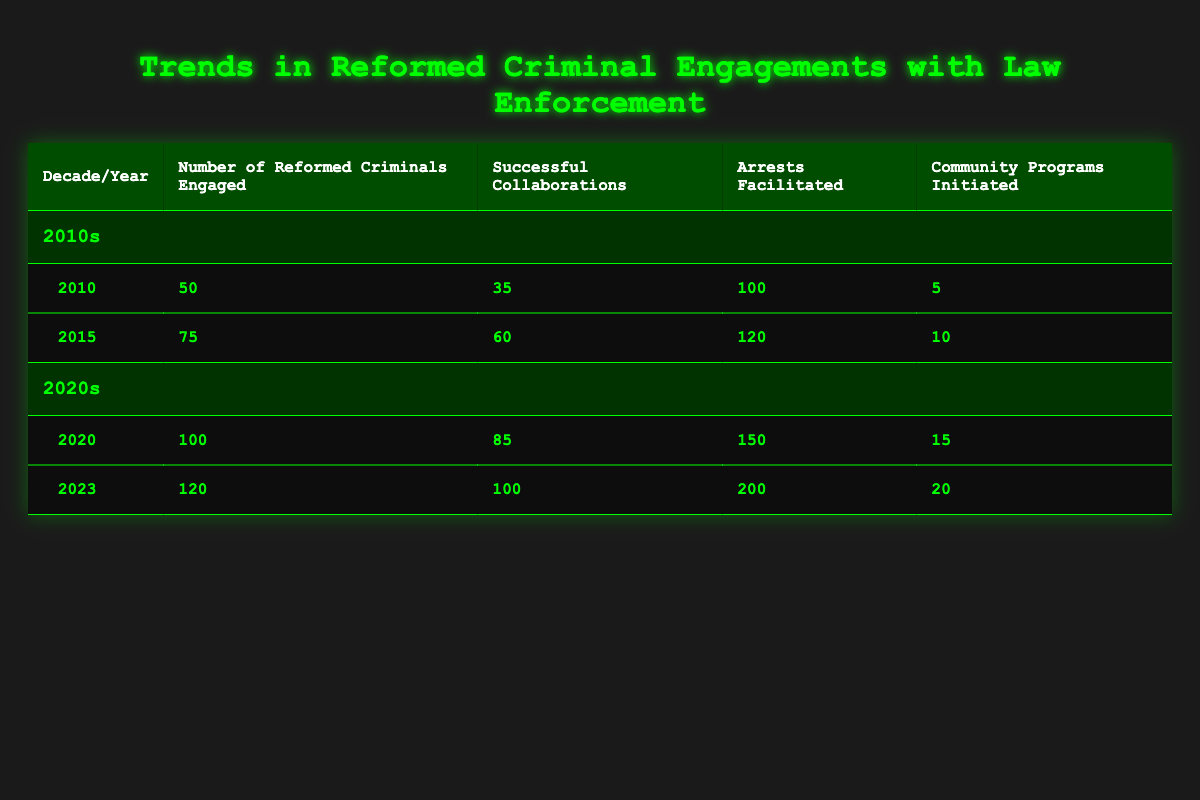What was the number of reformed criminals engaged in 2010? The table indicates that in 2010, the number of reformed criminals engaged was 50.
Answer: 50 How many successful collaborations were there in 2023? According to the table, in 2023, there were 100 successful collaborations.
Answer: 100 What is the total number of arrests facilitated throughout the decade of the 2010s? To find the total arrests facilitated in the 2010s, we add the arrests from 2010 and 2015: 100 (from 2010) + 120 (from 2015) = 220.
Answer: 220 Did the number of community programs initiated increase from 2010 to 2020? The table shows that in 2010, there were 5 community programs initiated, and in 2020, there were 15. Since 15 is greater than 5, the number did increase.
Answer: Yes What is the percentage increase in the number of reformed criminals engaged from 2015 to 2023? The number of reformed criminals engaged in 2015 was 75 and in 2023 it was 120. We calculate the percentage increase as ((120 - 75) / 75) * 100 = 60%.
Answer: 60% How many community programs were initiated in the 2020s compared to the 2010s? In the 2020s, the total community programs initiated (2020: 15 + 2023: 20) equals 35. In the 2010s, the total (2010: 5 + 2015: 10) equals 15. Thus, the 2020s had 35 - 15 = 20 more programs initiated.
Answer: 20 What was the average number of successful collaborations in the 2010s? To find the average, we total the successful collaborations: 35 (2010) + 60 (2015) = 95. There are 2 data points, so divide by 2: 95 / 2 = 47.5.
Answer: 47.5 Were more arrests facilitated in 2020 than in 2015? In 2020, the table shows 150 arrests facilitated and in 2015, there were 120. Since 150 is greater than 120, more arrests were indeed facilitated in 2020.
Answer: Yes What was the highest number of community programs initiated in a single year? By examining the table, the highest number of community programs initiated in a single year was 20 in 2023.
Answer: 20 